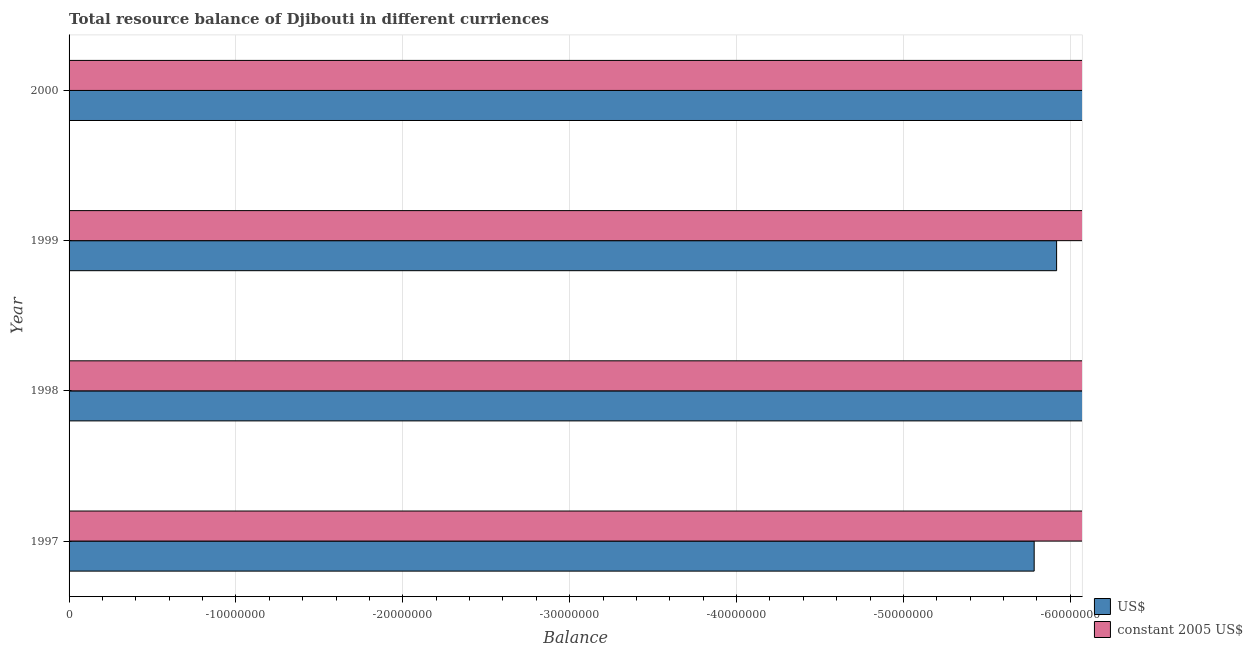How many different coloured bars are there?
Make the answer very short. 0. Are the number of bars per tick equal to the number of legend labels?
Your answer should be compact. No. What is the label of the 3rd group of bars from the top?
Your answer should be compact. 1998. What is the total resource balance in constant us$ in the graph?
Keep it short and to the point. 0. What is the difference between the resource balance in us$ in 1997 and the resource balance in constant us$ in 1999?
Your answer should be compact. 0. What is the average resource balance in us$ per year?
Make the answer very short. 0. In how many years, is the resource balance in us$ greater than -2000000 units?
Provide a short and direct response. 0. In how many years, is the resource balance in us$ greater than the average resource balance in us$ taken over all years?
Offer a terse response. 0. How many bars are there?
Your response must be concise. 0. Are all the bars in the graph horizontal?
Your answer should be compact. Yes. How many years are there in the graph?
Your answer should be very brief. 4. What is the difference between two consecutive major ticks on the X-axis?
Your answer should be compact. 1.00e+07. Where does the legend appear in the graph?
Provide a short and direct response. Bottom right. How many legend labels are there?
Provide a short and direct response. 2. How are the legend labels stacked?
Give a very brief answer. Vertical. What is the title of the graph?
Your response must be concise. Total resource balance of Djibouti in different curriences. What is the label or title of the X-axis?
Your answer should be compact. Balance. What is the Balance of US$ in 1997?
Your response must be concise. 0. What is the Balance in US$ in 1998?
Offer a very short reply. 0. What is the Balance in constant 2005 US$ in 2000?
Offer a very short reply. 0. What is the total Balance of US$ in the graph?
Offer a very short reply. 0. What is the average Balance in US$ per year?
Provide a short and direct response. 0. What is the average Balance in constant 2005 US$ per year?
Make the answer very short. 0. 